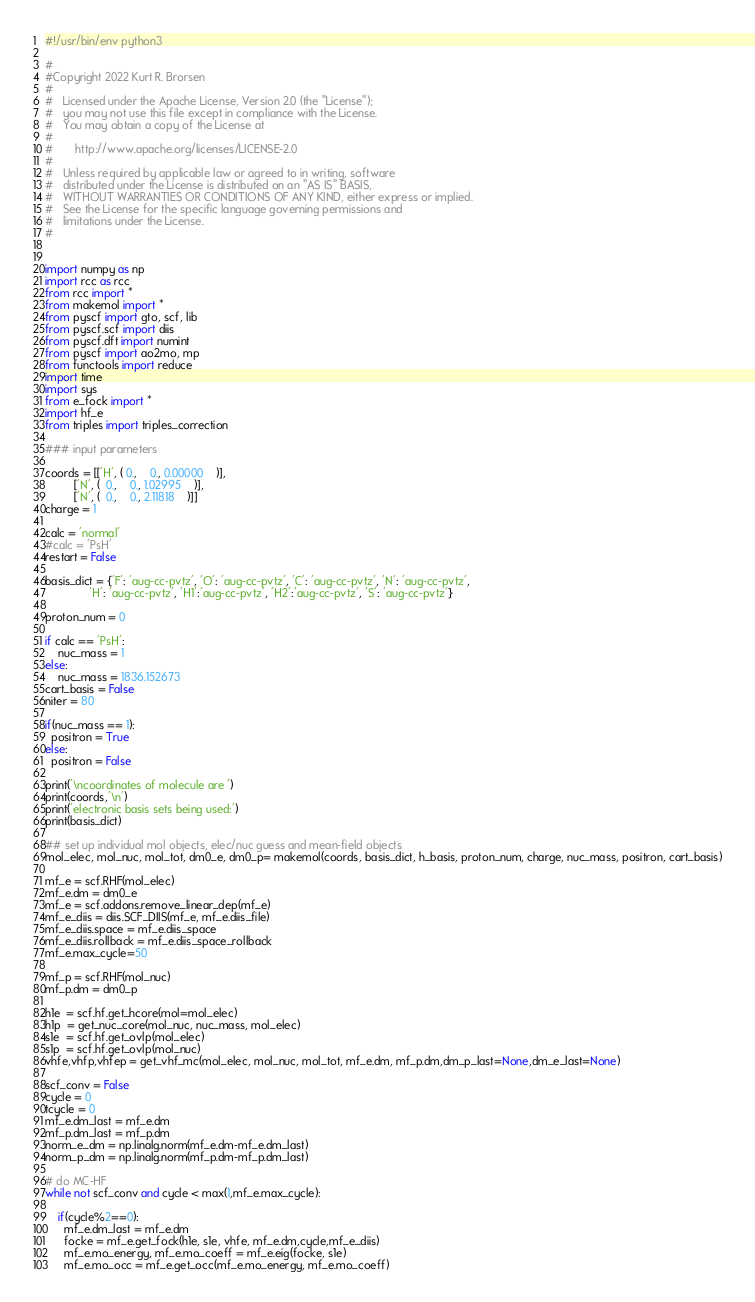Convert code to text. <code><loc_0><loc_0><loc_500><loc_500><_Python_>#!/usr/bin/env python3
  
#
#Copyright 2022 Kurt R. Brorsen
#
#   Licensed under the Apache License, Version 2.0 (the "License");
#   you may not use this file except in compliance with the License.
#   You may obtain a copy of the License at
#
#       http://www.apache.org/licenses/LICENSE-2.0
#
#   Unless required by applicable law or agreed to in writing, software
#   distributed under the License is distributed on an "AS IS" BASIS,
#   WITHOUT WARRANTIES OR CONDITIONS OF ANY KIND, either express or implied.
#   See the License for the specific language governing permissions and
#   limitations under the License.
#


import numpy as np
import rcc as rcc
from rcc import *
from makemol import *
from pyscf import gto, scf, lib
from pyscf.scf import diis
from pyscf.dft import numint
from pyscf import ao2mo, mp
from functools import reduce
import time
import sys
from e_fock import *
import hf_e
from triples import triples_correction 

### input parameters

coords = [['H', ( 0.,    0., 0.00000    )],
         ['N', (  0.,    0., 1.02995    )],
         ['N', (  0.,    0., 2.11818    )]]
charge = 1

calc = 'normal'
#calc = 'PsH'
restart = False

basis_dict = {'F': 'aug-cc-pvtz', 'O': 'aug-cc-pvtz', 'C': 'aug-cc-pvtz', 'N': 'aug-cc-pvtz',
              'H': 'aug-cc-pvtz', 'H1':'aug-cc-pvtz', 'H2':'aug-cc-pvtz', 'S': 'aug-cc-pvtz'}

proton_num = 0

if calc == 'PsH':
    nuc_mass = 1
else:
    nuc_mass = 1836.152673
cart_basis = False 
niter = 80

if(nuc_mass == 1):
  positron = True
else:
  positron = False

print('\ncoordinates of molecule are ')
print(coords,'\n')
print('electronic basis sets being used:')
print(basis_dict)

## set up individual mol objects, elec/nuc guess and mean-field objects
mol_elec, mol_nuc, mol_tot, dm0_e, dm0_p= makemol(coords, basis_dict, h_basis, proton_num, charge, nuc_mass, positron, cart_basis)

mf_e = scf.RHF(mol_elec)
mf_e.dm = dm0_e
mf_e = scf.addons.remove_linear_dep(mf_e)
mf_e_diis = diis.SCF_DIIS(mf_e, mf_e.diis_file)
mf_e_diis.space = mf_e.diis_space
mf_e_diis.rollback = mf_e.diis_space_rollback
mf_e.max_cycle=50

mf_p = scf.RHF(mol_nuc)
mf_p.dm = dm0_p

h1e  = scf.hf.get_hcore(mol=mol_elec)
h1p  = get_nuc_core(mol_nuc, nuc_mass, mol_elec)
s1e  = scf.hf.get_ovlp(mol_elec)
s1p  = scf.hf.get_ovlp(mol_nuc)
vhfe,vhfp,vhfep = get_vhf_mc(mol_elec, mol_nuc, mol_tot, mf_e.dm, mf_p.dm,dm_p_last=None,dm_e_last=None)

scf_conv = False
cycle = 0
tcycle = 0
mf_e.dm_last = mf_e.dm
mf_p.dm_last = mf_p.dm
norm_e_dm = np.linalg.norm(mf_e.dm-mf_e.dm_last)
norm_p_dm = np.linalg.norm(mf_p.dm-mf_p.dm_last)

# do MC-HF
while not scf_conv and cycle < max(1,mf_e.max_cycle):

    if(cycle%2==0):
      mf_e.dm_last = mf_e.dm
      focke = mf_e.get_fock(h1e, s1e, vhfe, mf_e.dm,cycle,mf_e_diis)
      mf_e.mo_energy, mf_e.mo_coeff = mf_e.eig(focke, s1e)
      mf_e.mo_occ = mf_e.get_occ(mf_e.mo_energy, mf_e.mo_coeff)</code> 